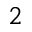Convert formula to latex. <formula><loc_0><loc_0><loc_500><loc_500>_ { 2 }</formula> 